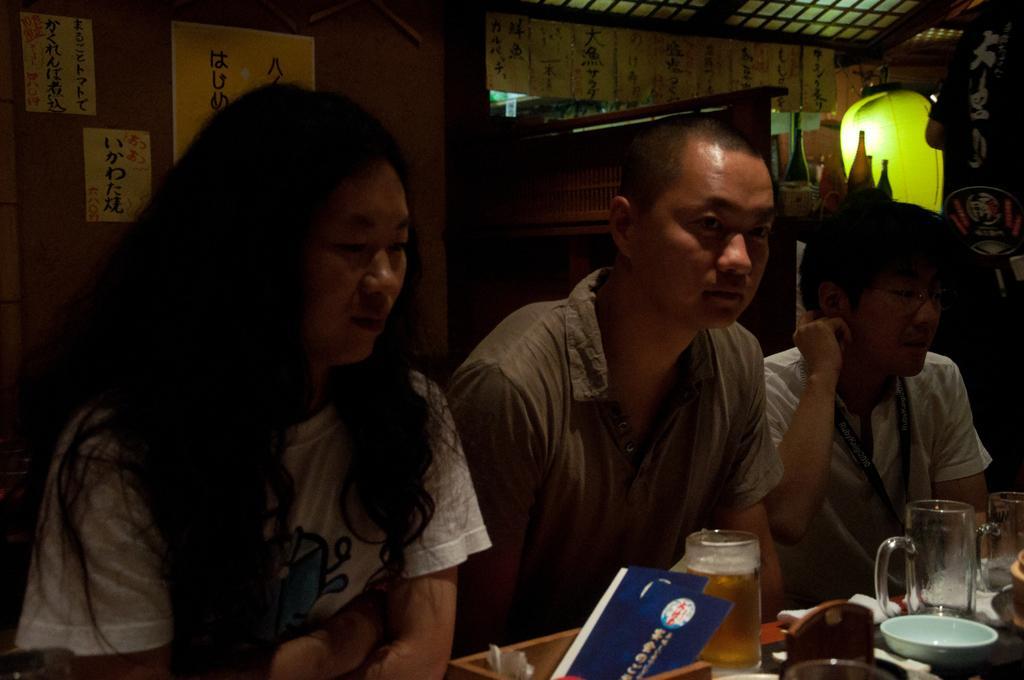Could you give a brief overview of what you see in this image? In the image we can see there are people who are sitting on chair and on table there are wine glass and a bowl. 